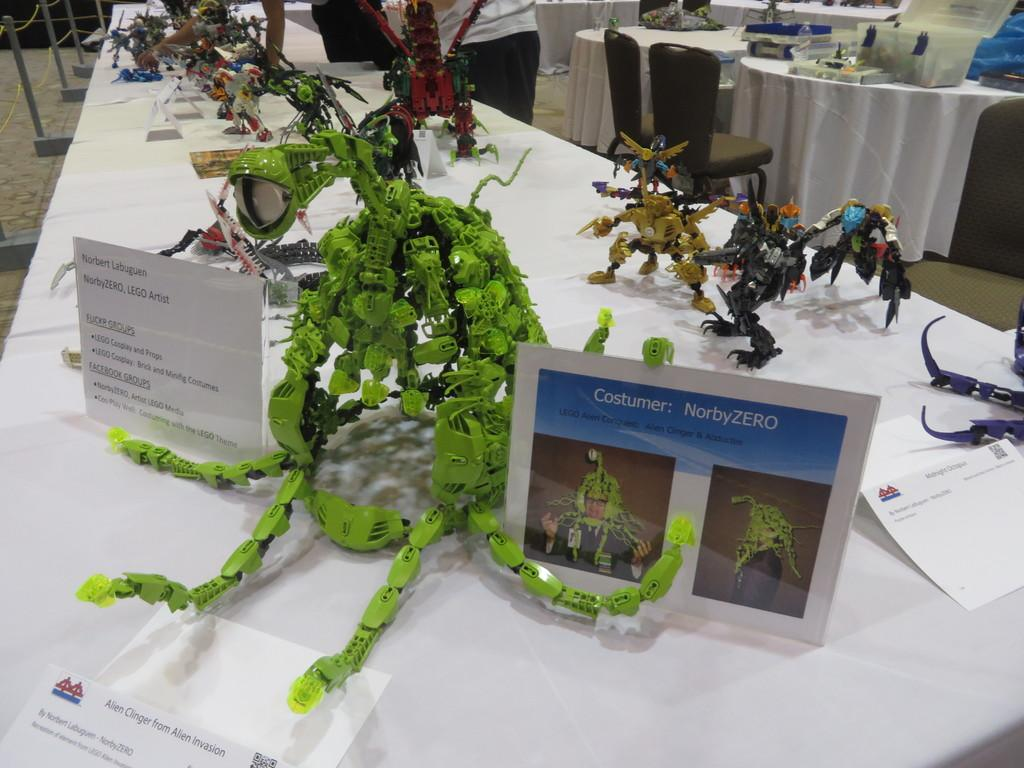What is the main subject in the image? There is a person standing at the top center of the image. What else can be seen in the image besides the person? There are objects placed on a table in the image. What suggestion does the person make in the image? There is no indication of any suggestion being made in the image. 